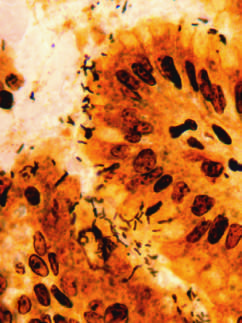how are spiral-shaped helicobacter pylori bacilli?
Answer the question using a single word or phrase. Highlighted in this warthin-starry silver stain 